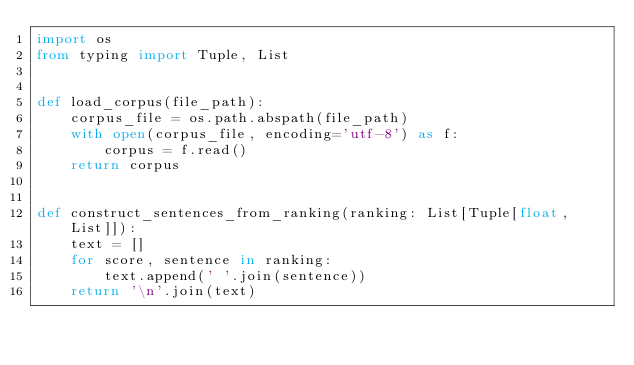<code> <loc_0><loc_0><loc_500><loc_500><_Python_>import os
from typing import Tuple, List


def load_corpus(file_path):
    corpus_file = os.path.abspath(file_path)
    with open(corpus_file, encoding='utf-8') as f:
        corpus = f.read()
    return corpus


def construct_sentences_from_ranking(ranking: List[Tuple[float, List]]):
    text = []
    for score, sentence in ranking:
        text.append(' '.join(sentence))
    return '\n'.join(text)
</code> 